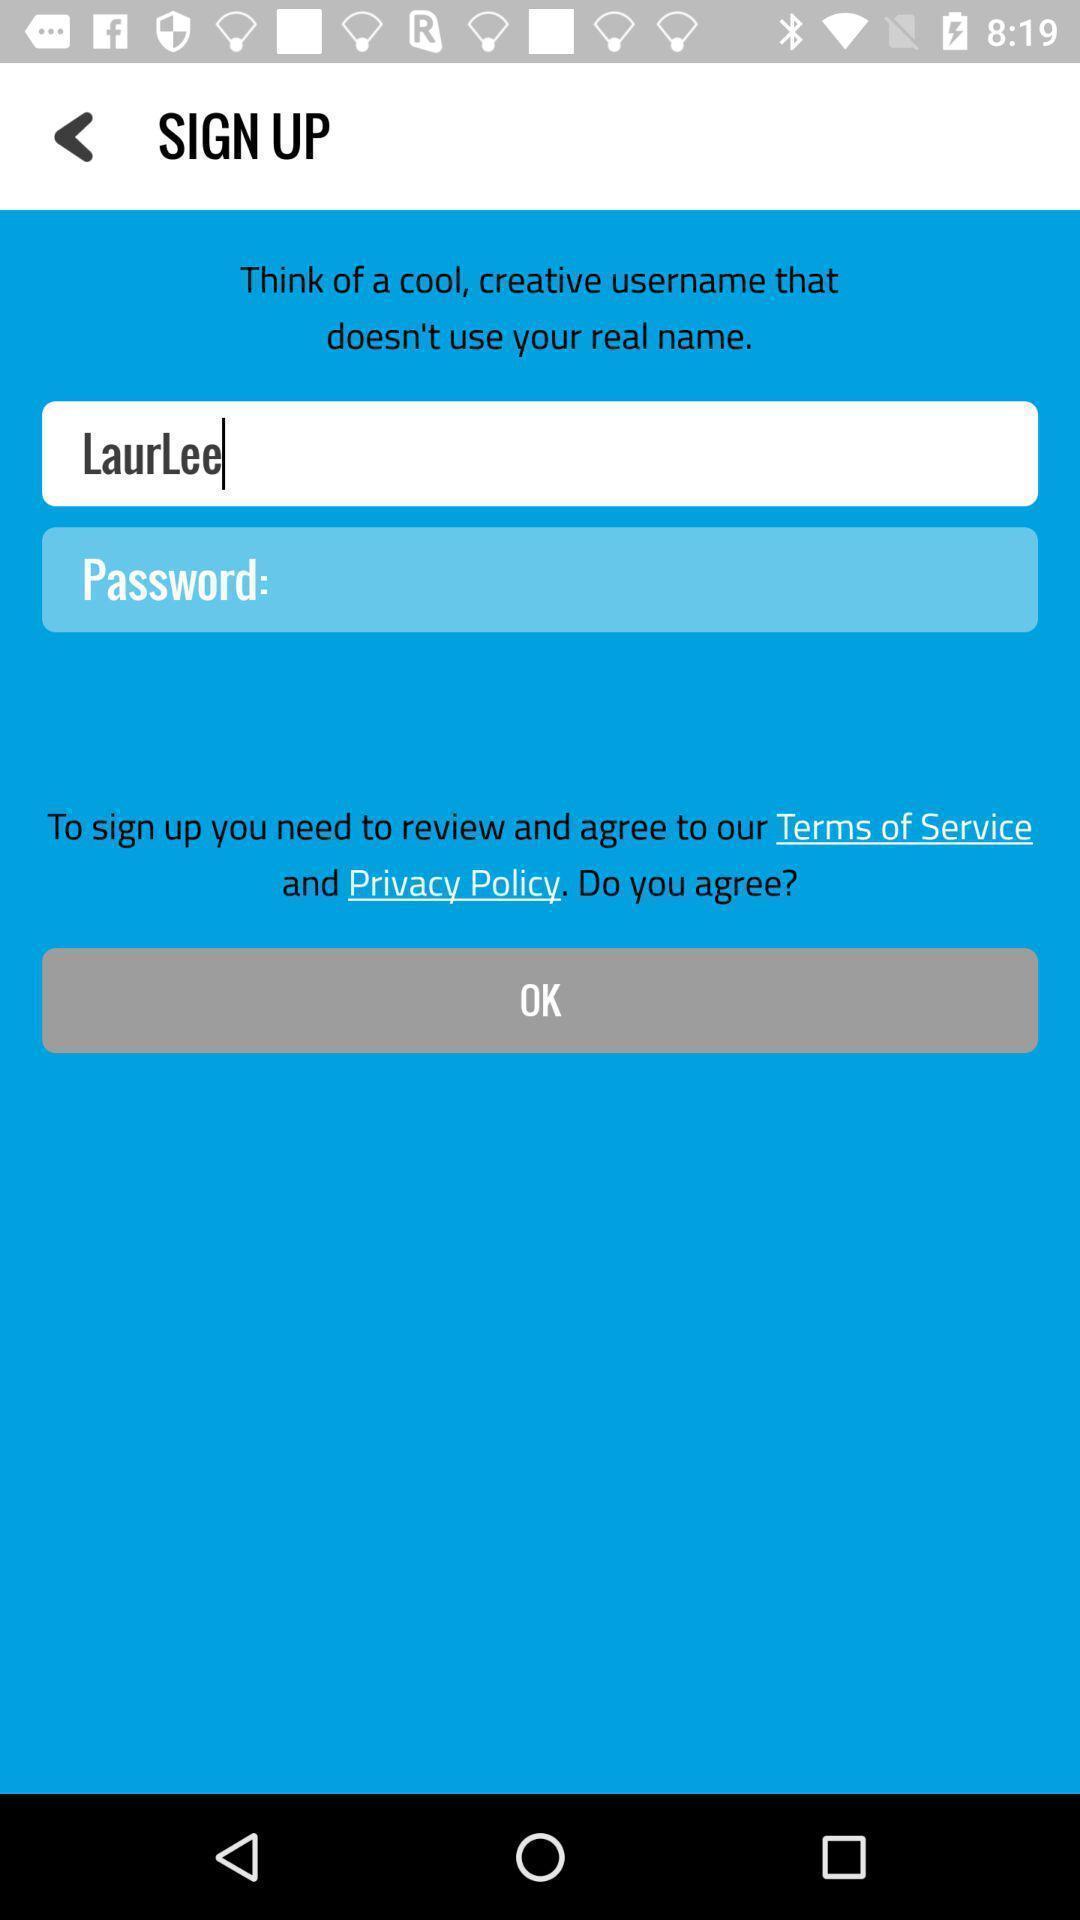What can you discern from this picture? Sign up page of laura lee. 